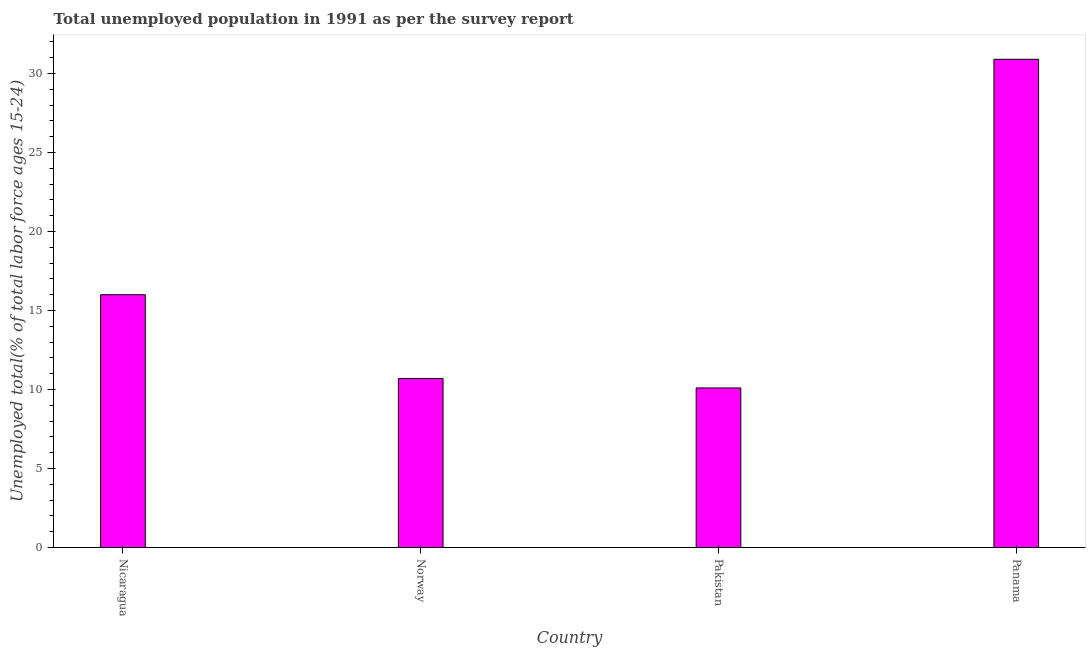Does the graph contain any zero values?
Offer a terse response. No. What is the title of the graph?
Give a very brief answer. Total unemployed population in 1991 as per the survey report. What is the label or title of the X-axis?
Your response must be concise. Country. What is the label or title of the Y-axis?
Ensure brevity in your answer.  Unemployed total(% of total labor force ages 15-24). What is the unemployed youth in Panama?
Offer a very short reply. 30.9. Across all countries, what is the maximum unemployed youth?
Offer a very short reply. 30.9. Across all countries, what is the minimum unemployed youth?
Give a very brief answer. 10.1. In which country was the unemployed youth maximum?
Provide a short and direct response. Panama. What is the sum of the unemployed youth?
Offer a terse response. 67.7. What is the difference between the unemployed youth in Nicaragua and Panama?
Your answer should be compact. -14.9. What is the average unemployed youth per country?
Provide a short and direct response. 16.93. What is the median unemployed youth?
Offer a terse response. 13.35. What is the ratio of the unemployed youth in Norway to that in Pakistan?
Offer a very short reply. 1.06. Is the unemployed youth in Norway less than that in Panama?
Provide a short and direct response. Yes. Is the difference between the unemployed youth in Nicaragua and Panama greater than the difference between any two countries?
Offer a terse response. No. What is the difference between the highest and the lowest unemployed youth?
Offer a terse response. 20.8. What is the Unemployed total(% of total labor force ages 15-24) of Nicaragua?
Provide a short and direct response. 16. What is the Unemployed total(% of total labor force ages 15-24) of Norway?
Your response must be concise. 10.7. What is the Unemployed total(% of total labor force ages 15-24) in Pakistan?
Keep it short and to the point. 10.1. What is the Unemployed total(% of total labor force ages 15-24) of Panama?
Make the answer very short. 30.9. What is the difference between the Unemployed total(% of total labor force ages 15-24) in Nicaragua and Panama?
Offer a terse response. -14.9. What is the difference between the Unemployed total(% of total labor force ages 15-24) in Norway and Pakistan?
Offer a terse response. 0.6. What is the difference between the Unemployed total(% of total labor force ages 15-24) in Norway and Panama?
Ensure brevity in your answer.  -20.2. What is the difference between the Unemployed total(% of total labor force ages 15-24) in Pakistan and Panama?
Offer a very short reply. -20.8. What is the ratio of the Unemployed total(% of total labor force ages 15-24) in Nicaragua to that in Norway?
Offer a terse response. 1.5. What is the ratio of the Unemployed total(% of total labor force ages 15-24) in Nicaragua to that in Pakistan?
Make the answer very short. 1.58. What is the ratio of the Unemployed total(% of total labor force ages 15-24) in Nicaragua to that in Panama?
Ensure brevity in your answer.  0.52. What is the ratio of the Unemployed total(% of total labor force ages 15-24) in Norway to that in Pakistan?
Provide a short and direct response. 1.06. What is the ratio of the Unemployed total(% of total labor force ages 15-24) in Norway to that in Panama?
Make the answer very short. 0.35. What is the ratio of the Unemployed total(% of total labor force ages 15-24) in Pakistan to that in Panama?
Make the answer very short. 0.33. 